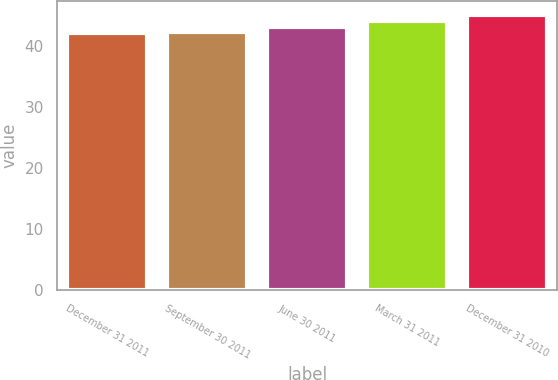Convert chart. <chart><loc_0><loc_0><loc_500><loc_500><bar_chart><fcel>December 31 2011<fcel>September 30 2011<fcel>June 30 2011<fcel>March 31 2011<fcel>December 31 2010<nl><fcel>42<fcel>42.3<fcel>43<fcel>44<fcel>45<nl></chart> 